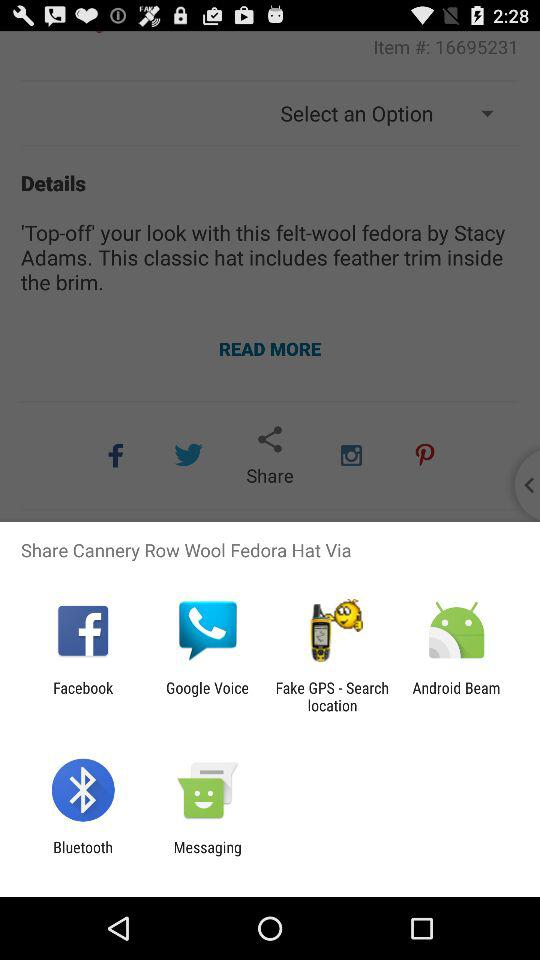What does a wool fedora hat include? The wool fedora hat includes "feather trim inside the brim". 